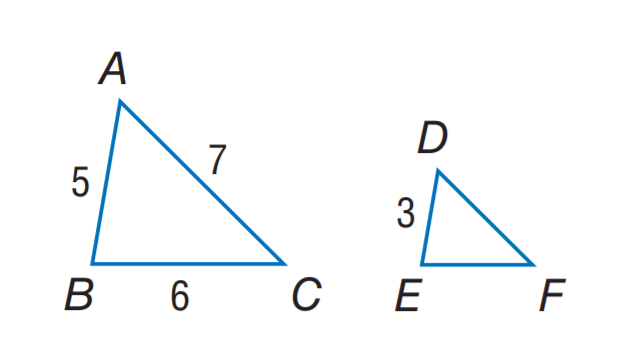Answer the mathemtical geometry problem and directly provide the correct option letter.
Question: Find the perimeter of the \triangle D E F, if \triangle A B C \sim \triangle D E F, A B = 5, B C = 6, A C = 7, and D E = 3.
Choices: A: 6 B: 10.2 C: 10.8 D: 13 C 